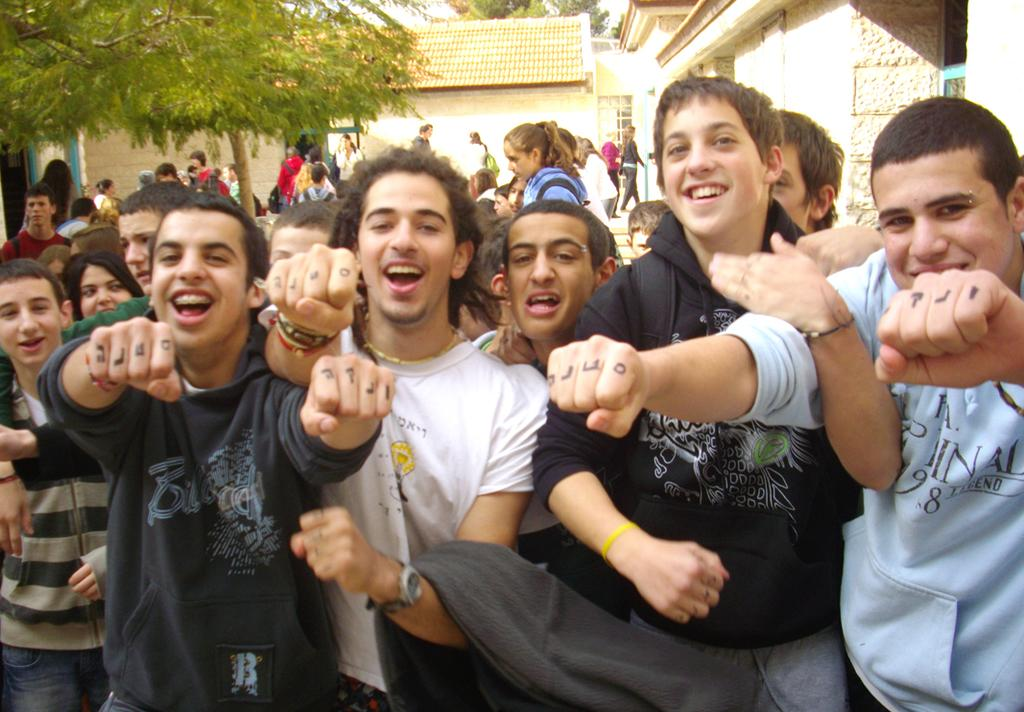How many people are present in the image? There is a group of people standing in the image, but the exact number cannot be determined from the provided facts. What can be seen in the background of the image? There are buildings and trees with green color in the background of the image. What type of list can be seen on the ground in the image? There is no list present in the image. 